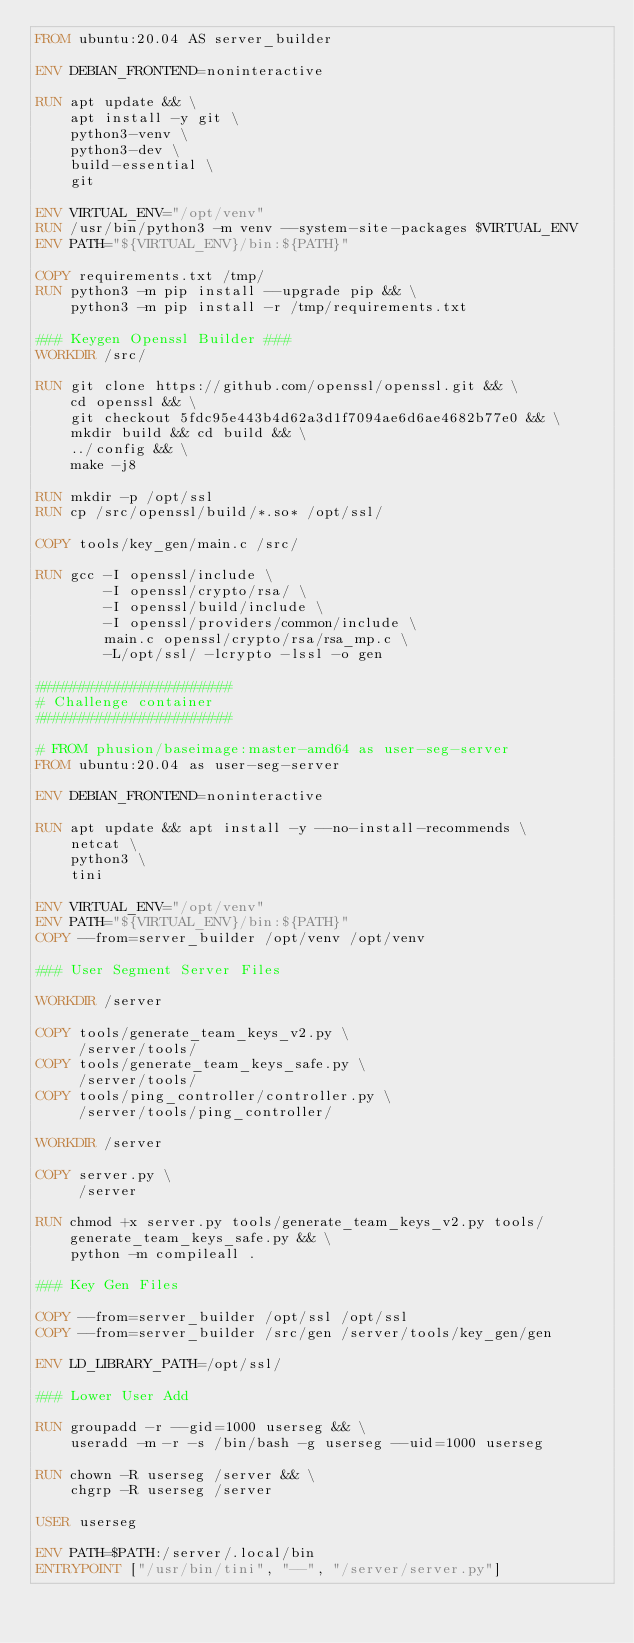<code> <loc_0><loc_0><loc_500><loc_500><_Dockerfile_>FROM ubuntu:20.04 AS server_builder

ENV DEBIAN_FRONTEND=noninteractive

RUN apt update && \
    apt install -y git \
    python3-venv \
    python3-dev \
    build-essential \
    git

ENV VIRTUAL_ENV="/opt/venv"
RUN /usr/bin/python3 -m venv --system-site-packages $VIRTUAL_ENV
ENV PATH="${VIRTUAL_ENV}/bin:${PATH}"

COPY requirements.txt /tmp/
RUN python3 -m pip install --upgrade pip && \
    python3 -m pip install -r /tmp/requirements.txt 

### Keygen Openssl Builder ###
WORKDIR /src/

RUN git clone https://github.com/openssl/openssl.git && \
    cd openssl && \
    git checkout 5fdc95e443b4d62a3d1f7094ae6d6ae4682b77e0 && \
    mkdir build && cd build && \
    ../config && \
    make -j8

RUN mkdir -p /opt/ssl
RUN cp /src/openssl/build/*.so* /opt/ssl/

COPY tools/key_gen/main.c /src/

RUN gcc -I openssl/include \
        -I openssl/crypto/rsa/ \
        -I openssl/build/include \
        -I openssl/providers/common/include \
        main.c openssl/crypto/rsa/rsa_mp.c \
        -L/opt/ssl/ -lcrypto -lssl -o gen

#######################
# Challenge container
#######################

# FROM phusion/baseimage:master-amd64 as user-seg-server
FROM ubuntu:20.04 as user-seg-server

ENV DEBIAN_FRONTEND=noninteractive

RUN apt update && apt install -y --no-install-recommends \
    netcat \
    python3 \
    tini

ENV VIRTUAL_ENV="/opt/venv"
ENV PATH="${VIRTUAL_ENV}/bin:${PATH}"
COPY --from=server_builder /opt/venv /opt/venv

### User Segment Server Files

WORKDIR /server

COPY tools/generate_team_keys_v2.py \
     /server/tools/
COPY tools/generate_team_keys_safe.py \
     /server/tools/
COPY tools/ping_controller/controller.py \
     /server/tools/ping_controller/

WORKDIR /server

COPY server.py \
     /server

RUN chmod +x server.py tools/generate_team_keys_v2.py tools/generate_team_keys_safe.py && \
    python -m compileall .

### Key Gen Files

COPY --from=server_builder /opt/ssl /opt/ssl
COPY --from=server_builder /src/gen /server/tools/key_gen/gen

ENV LD_LIBRARY_PATH=/opt/ssl/

### Lower User Add

RUN groupadd -r --gid=1000 userseg && \
    useradd -m -r -s /bin/bash -g userseg --uid=1000 userseg

RUN chown -R userseg /server && \
    chgrp -R userseg /server

USER userseg

ENV PATH=$PATH:/server/.local/bin
ENTRYPOINT ["/usr/bin/tini", "--", "/server/server.py"]</code> 